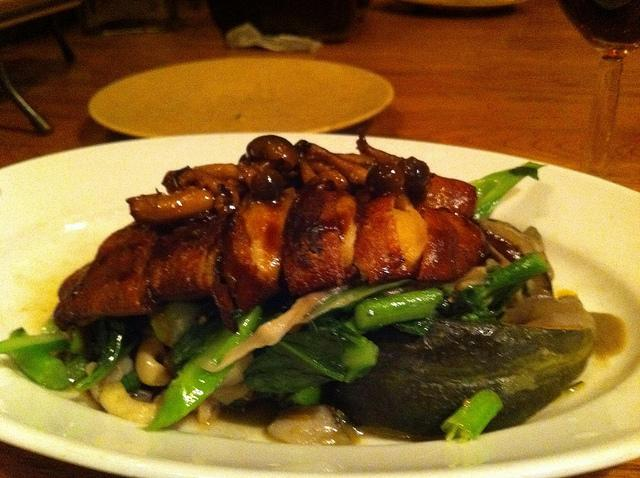What has caused the food on the plate to look shiny? Please explain your reasoning. sauce. The plate is covered in sauce. 